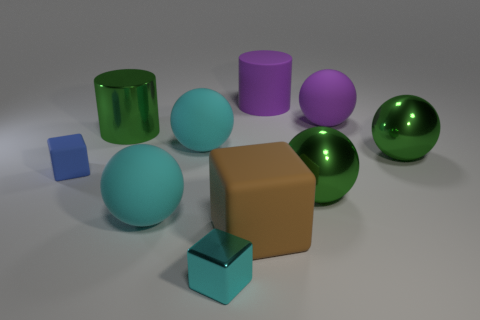How many other objects are the same color as the large metallic cylinder?
Make the answer very short. 2. What number of purple things are big blocks or big rubber cylinders?
Offer a very short reply. 1. There is a thing on the left side of the large shiny thing that is on the left side of the big cube; is there a cyan sphere left of it?
Your response must be concise. No. Is there any other thing that is the same size as the matte cylinder?
Give a very brief answer. Yes. Is the small rubber block the same color as the metallic block?
Make the answer very short. No. What color is the large metallic thing on the right side of the large metal object in front of the blue rubber thing?
Give a very brief answer. Green. How many big things are either shiny things or cylinders?
Your answer should be very brief. 4. What is the color of the metallic thing that is both behind the big brown thing and to the left of the large brown rubber object?
Offer a terse response. Green. Are the cyan cube and the large block made of the same material?
Offer a very short reply. No. What shape is the tiny matte object?
Your answer should be compact. Cube. 